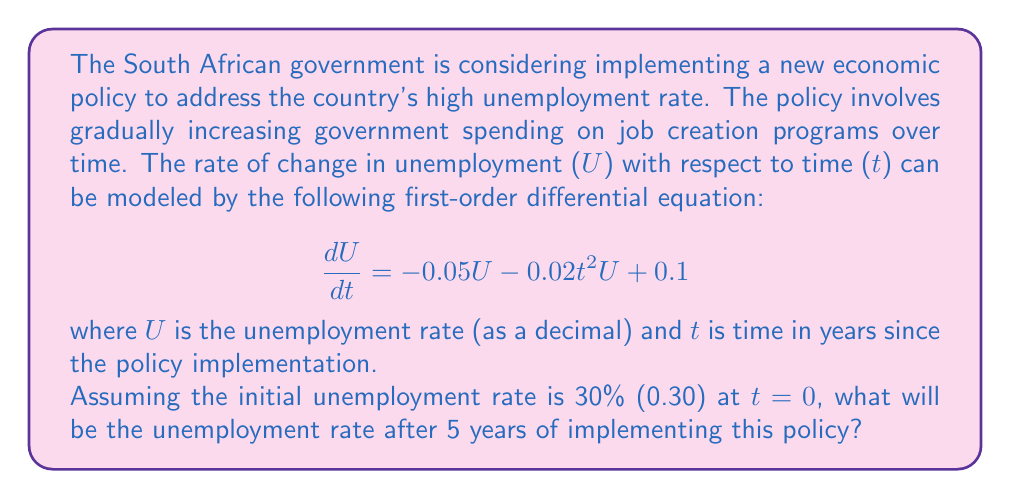Show me your answer to this math problem. To solve this first-order differential equation with time-dependent coefficients, we'll use the integrating factor method:

1) First, rewrite the equation in standard form:
   $$\frac{dU}{dt} + (0.05 + 0.02t^2)U = 0.1$$

2) The integrating factor is:
   $$\mu(t) = e^{\int (0.05 + 0.02t^2) dt} = e^{0.05t + \frac{0.02t^3}{3}}$$

3) Multiply both sides of the equation by the integrating factor:
   $$e^{0.05t + \frac{0.02t^3}{3}} \frac{dU}{dt} + (0.05 + 0.02t^2)e^{0.05t + \frac{0.02t^3}{3}}U = 0.1e^{0.05t + \frac{0.02t^3}{3}}$$

4) The left side is now the derivative of $Ue^{0.05t + \frac{0.02t^3}{3}}$, so we can integrate both sides:
   $$Ue^{0.05t + \frac{0.02t^3}{3}} = \int 0.1e^{0.05t + \frac{0.02t^3}{3}} dt + C$$

5) The integral on the right side doesn't have a simple closed form. We'll call it $F(t)$:
   $$U = e^{-0.05t - \frac{0.02t^3}{3}}(F(t) + C)$$

6) Use the initial condition U(0) = 0.30 to find C:
   $$0.30 = F(0) + C$$
   $$C = 0.30 - F(0)$$

7) The final solution is:
   $$U(t) = e^{-0.05t - \frac{0.02t^3}{3}}(F(t) + 0.30 - F(0))$$

8) To find U(5), we need to evaluate F(5) and F(0) numerically. Using a numerical integration method (like Simpson's rule or a computer algebra system), we get:
   F(5) ≈ 0.5231
   F(0) = 0

9) Plugging in t = 5:
   $$U(5) = e^{-0.05(5) - \frac{0.02(5^3)}{3}}(0.5231 + 0.30 - 0) ≈ 0.2168$$
Answer: After 5 years of implementing the policy, the unemployment rate will be approximately 21.68%. 